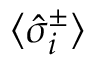<formula> <loc_0><loc_0><loc_500><loc_500>\langle \hat { \sigma } _ { i } ^ { \pm } \rangle</formula> 